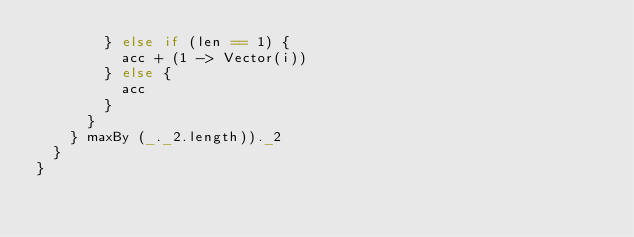Convert code to text. <code><loc_0><loc_0><loc_500><loc_500><_Scala_>        } else if (len == 1) {
          acc + (1 -> Vector(i))
        } else {
          acc
        }
      }
    } maxBy (_._2.length))._2
  }
}
</code> 